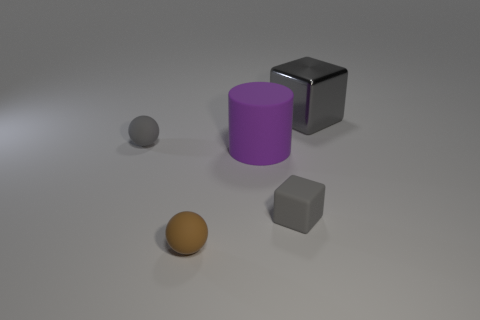Is the shape of the purple thing the same as the metallic thing?
Provide a succinct answer. No. Are there an equal number of gray cubes right of the large gray block and cylinders that are right of the big purple object?
Give a very brief answer. Yes. What number of other objects are there of the same material as the tiny brown object?
Provide a short and direct response. 3. What number of small objects are either brown balls or rubber objects?
Make the answer very short. 3. Are there an equal number of big purple rubber objects to the right of the purple cylinder and big purple rubber cylinders?
Offer a very short reply. No. There is a tiny gray object that is on the right side of the gray ball; is there a small matte thing that is behind it?
Your answer should be very brief. Yes. How many other things are there of the same color as the tiny block?
Provide a short and direct response. 2. The shiny cube is what color?
Keep it short and to the point. Gray. There is a gray object that is to the right of the brown rubber ball and behind the purple matte object; what size is it?
Keep it short and to the point. Large. How many things are either objects that are left of the big block or large cylinders?
Your answer should be very brief. 4. 